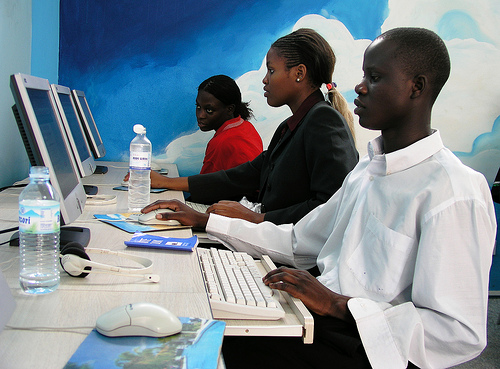<image>
Is the water bottle on the mouse? No. The water bottle is not positioned on the mouse. They may be near each other, but the water bottle is not supported by or resting on top of the mouse. Is the man to the left of the woman? Yes. From this viewpoint, the man is positioned to the left side relative to the woman. Is there a woman in front of the keyboard? No. The woman is not in front of the keyboard. The spatial positioning shows a different relationship between these objects. 